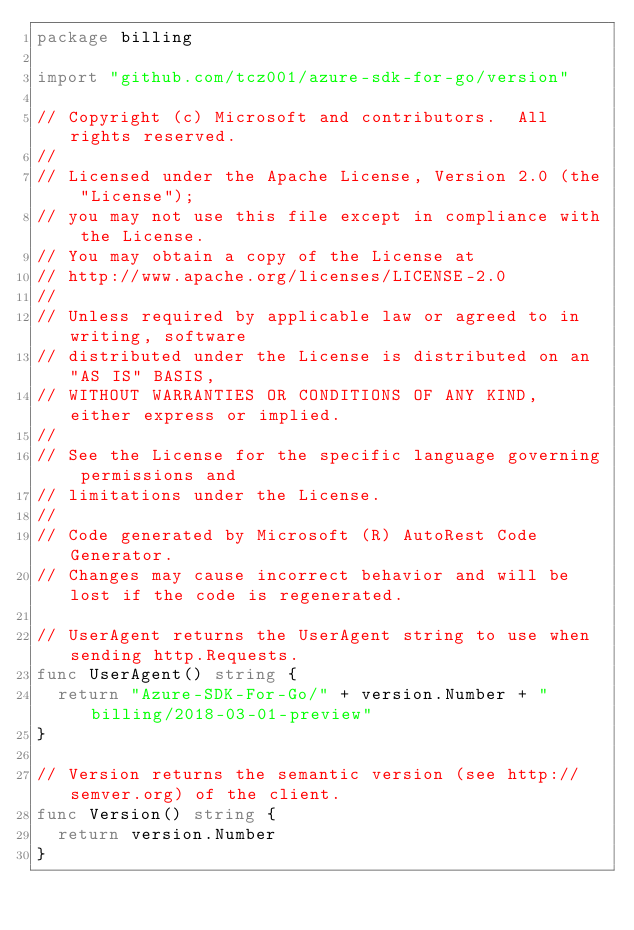Convert code to text. <code><loc_0><loc_0><loc_500><loc_500><_Go_>package billing

import "github.com/tcz001/azure-sdk-for-go/version"

// Copyright (c) Microsoft and contributors.  All rights reserved.
//
// Licensed under the Apache License, Version 2.0 (the "License");
// you may not use this file except in compliance with the License.
// You may obtain a copy of the License at
// http://www.apache.org/licenses/LICENSE-2.0
//
// Unless required by applicable law or agreed to in writing, software
// distributed under the License is distributed on an "AS IS" BASIS,
// WITHOUT WARRANTIES OR CONDITIONS OF ANY KIND, either express or implied.
//
// See the License for the specific language governing permissions and
// limitations under the License.
//
// Code generated by Microsoft (R) AutoRest Code Generator.
// Changes may cause incorrect behavior and will be lost if the code is regenerated.

// UserAgent returns the UserAgent string to use when sending http.Requests.
func UserAgent() string {
	return "Azure-SDK-For-Go/" + version.Number + " billing/2018-03-01-preview"
}

// Version returns the semantic version (see http://semver.org) of the client.
func Version() string {
	return version.Number
}
</code> 